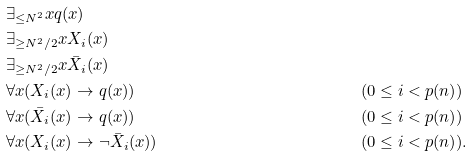<formula> <loc_0><loc_0><loc_500><loc_500>& \exists _ { \leq N ^ { 2 } } x q ( x ) \\ & \exists _ { \geq N ^ { 2 } / 2 } x X _ { i } ( x ) \\ & \exists _ { \geq N ^ { 2 } / 2 } x \bar { X } _ { i } ( x ) \\ & \forall x ( X _ { i } ( x ) \rightarrow q ( x ) ) & & ( 0 \leq i < p ( n ) ) \\ & \forall x ( \bar { X } _ { i } ( x ) \rightarrow q ( x ) ) & & ( 0 \leq i < p ( n ) ) \\ & \forall x ( X _ { i } ( x ) \rightarrow \neg \bar { X } _ { i } ( x ) ) & & ( 0 \leq i < p ( n ) ) .</formula> 